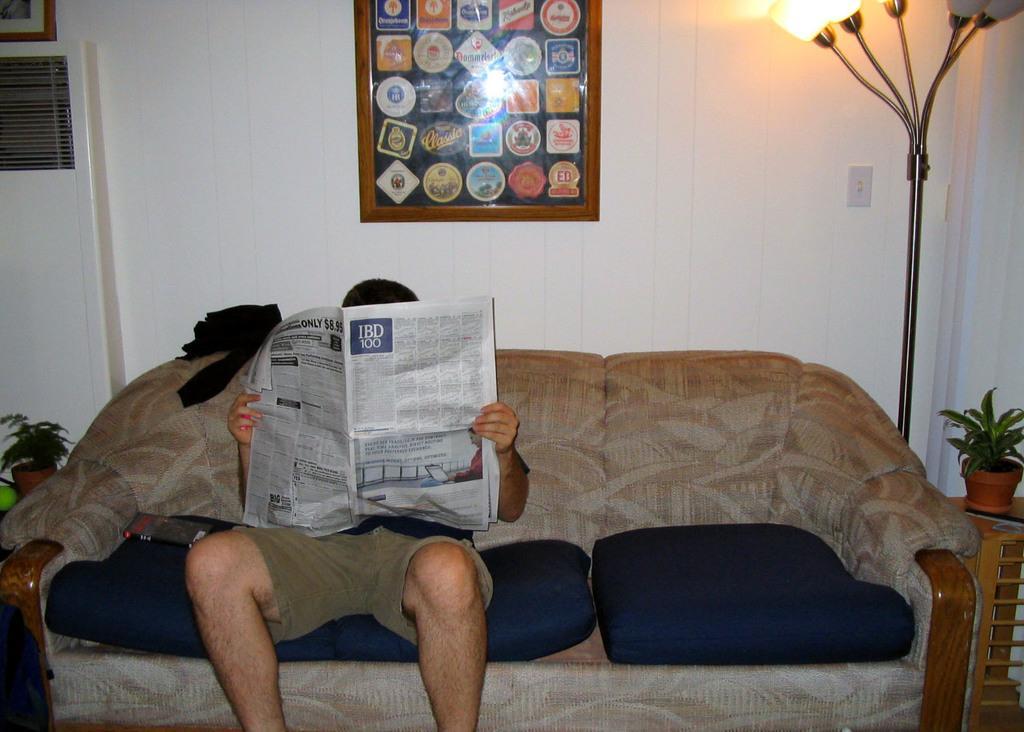Could you give a brief overview of what you see in this image? Here in the center we can see one person sitting on the couch and reading newspaper. Coming to the back ground there is a wall with photo frame and he is surrounded by few objects. 